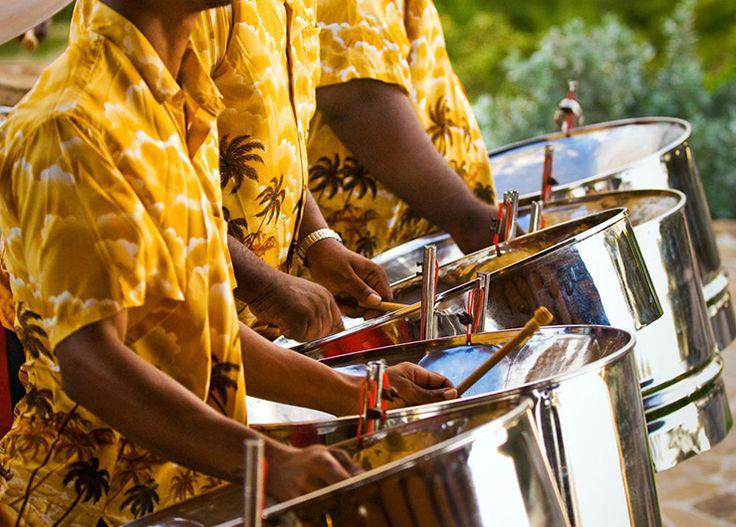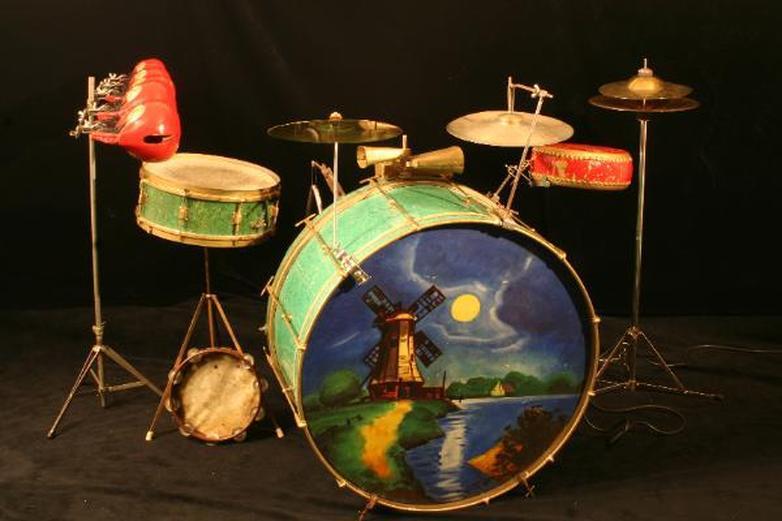The first image is the image on the left, the second image is the image on the right. Given the left and right images, does the statement "The left image contains a row of three musicians in matching shirts, and at least one of them holds drumsticks and has a steel drum at his front." hold true? Answer yes or no. Yes. The first image is the image on the left, the second image is the image on the right. Evaluate the accuracy of this statement regarding the images: "Exactly one person is playing steel drums.". Is it true? Answer yes or no. No. 